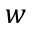<formula> <loc_0><loc_0><loc_500><loc_500>w</formula> 